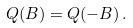Convert formula to latex. <formula><loc_0><loc_0><loc_500><loc_500>Q ( B ) = Q ( - B ) \, .</formula> 